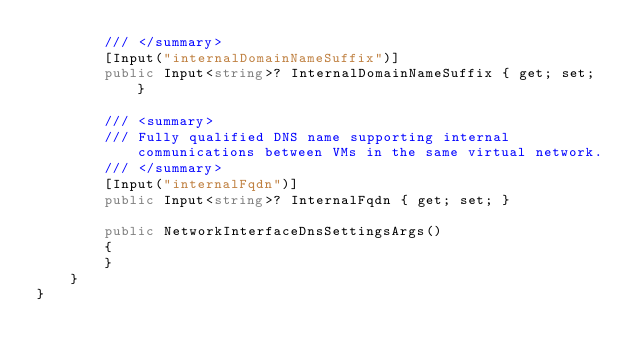Convert code to text. <code><loc_0><loc_0><loc_500><loc_500><_C#_>        /// </summary>
        [Input("internalDomainNameSuffix")]
        public Input<string>? InternalDomainNameSuffix { get; set; }

        /// <summary>
        /// Fully qualified DNS name supporting internal communications between VMs in the same virtual network.
        /// </summary>
        [Input("internalFqdn")]
        public Input<string>? InternalFqdn { get; set; }

        public NetworkInterfaceDnsSettingsArgs()
        {
        }
    }
}
</code> 